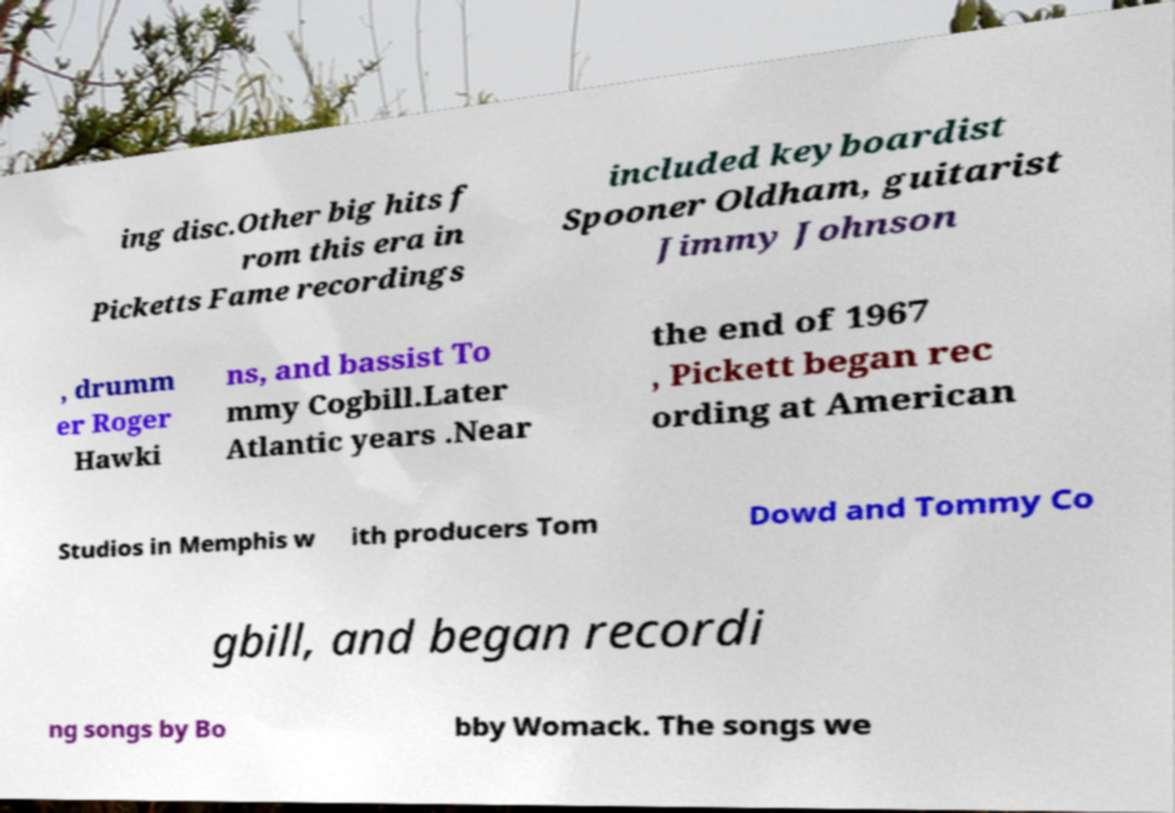Please identify and transcribe the text found in this image. ing disc.Other big hits f rom this era in Picketts Fame recordings included keyboardist Spooner Oldham, guitarist Jimmy Johnson , drumm er Roger Hawki ns, and bassist To mmy Cogbill.Later Atlantic years .Near the end of 1967 , Pickett began rec ording at American Studios in Memphis w ith producers Tom Dowd and Tommy Co gbill, and began recordi ng songs by Bo bby Womack. The songs we 